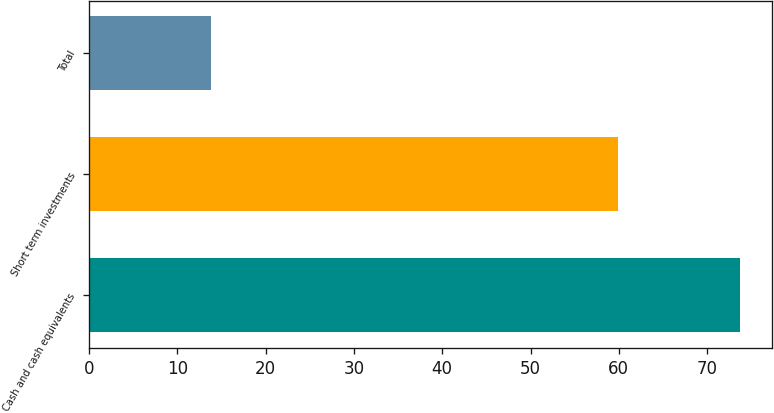<chart> <loc_0><loc_0><loc_500><loc_500><bar_chart><fcel>Cash and cash equivalents<fcel>Short term investments<fcel>Total<nl><fcel>73.7<fcel>59.9<fcel>13.8<nl></chart> 